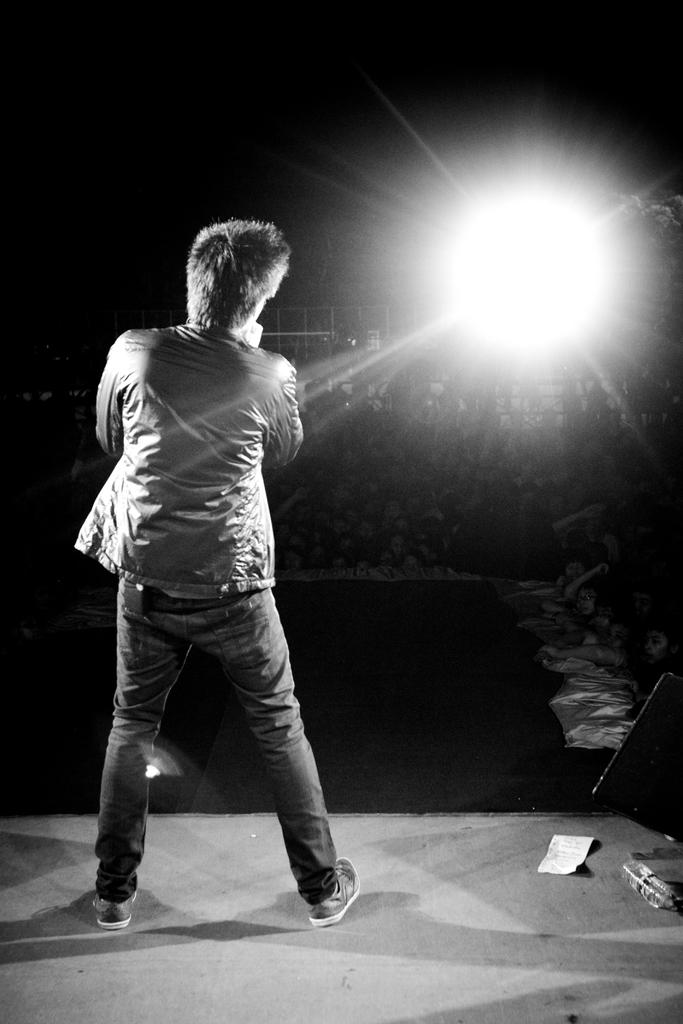What is the position of the person in the image? There is a person standing on the left side of the image. What can be seen on the right side of the image? There is light on the right side of the image. How would you describe the lighting at the top of the image? The top of the image appears to be dark. What type of structure is in the middle of the image? There is a fencing-like structure in the middle of the image. What type of canvas is the person holding in the image? There is no canvas present in the image. What suggestion does the turkey make to the person in the image? There is no turkey present in the image, so it cannot make any suggestions. 